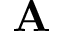<formula> <loc_0><loc_0><loc_500><loc_500>{ A }</formula> 